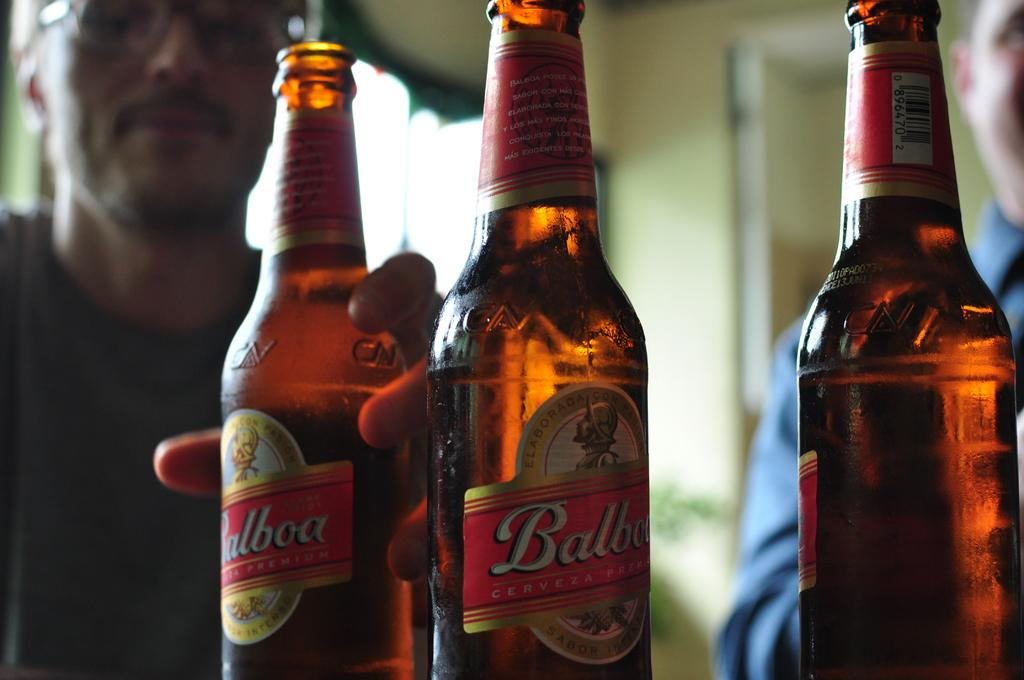Provide a one-sentence caption for the provided image. Three bottles of Balboa beer are sitting in front of two men. 